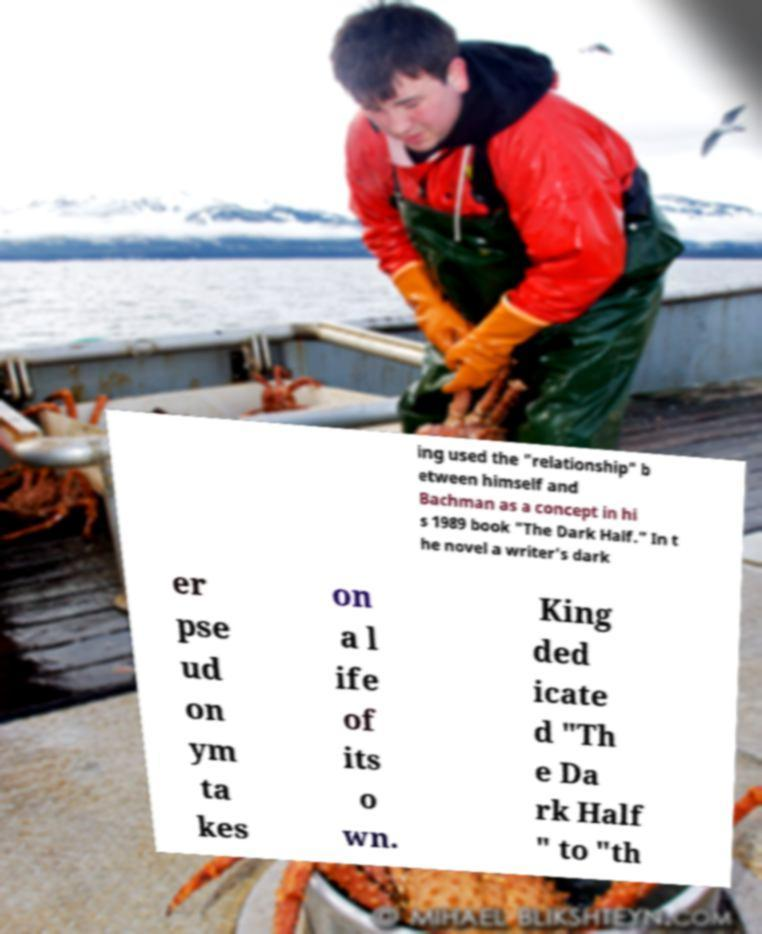Can you accurately transcribe the text from the provided image for me? ing used the "relationship" b etween himself and Bachman as a concept in hi s 1989 book "The Dark Half." In t he novel a writer's dark er pse ud on ym ta kes on a l ife of its o wn. King ded icate d "Th e Da rk Half " to "th 